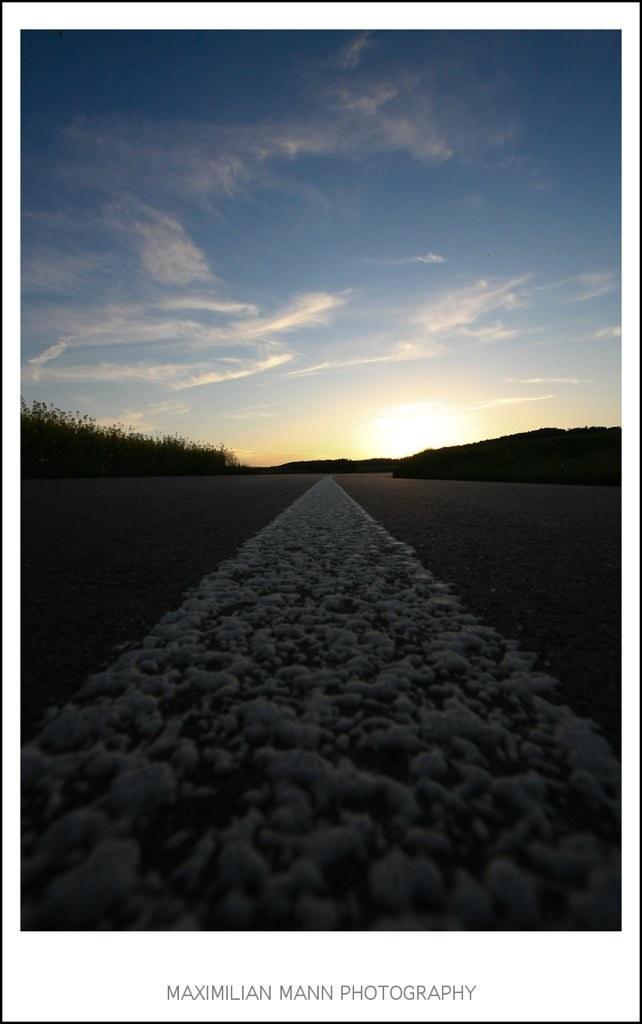How would you summarize this image in a sentence or two? In this image we can see the road, trees, hills, sun and sky with clouds in the background. Here we can see some edited text. 